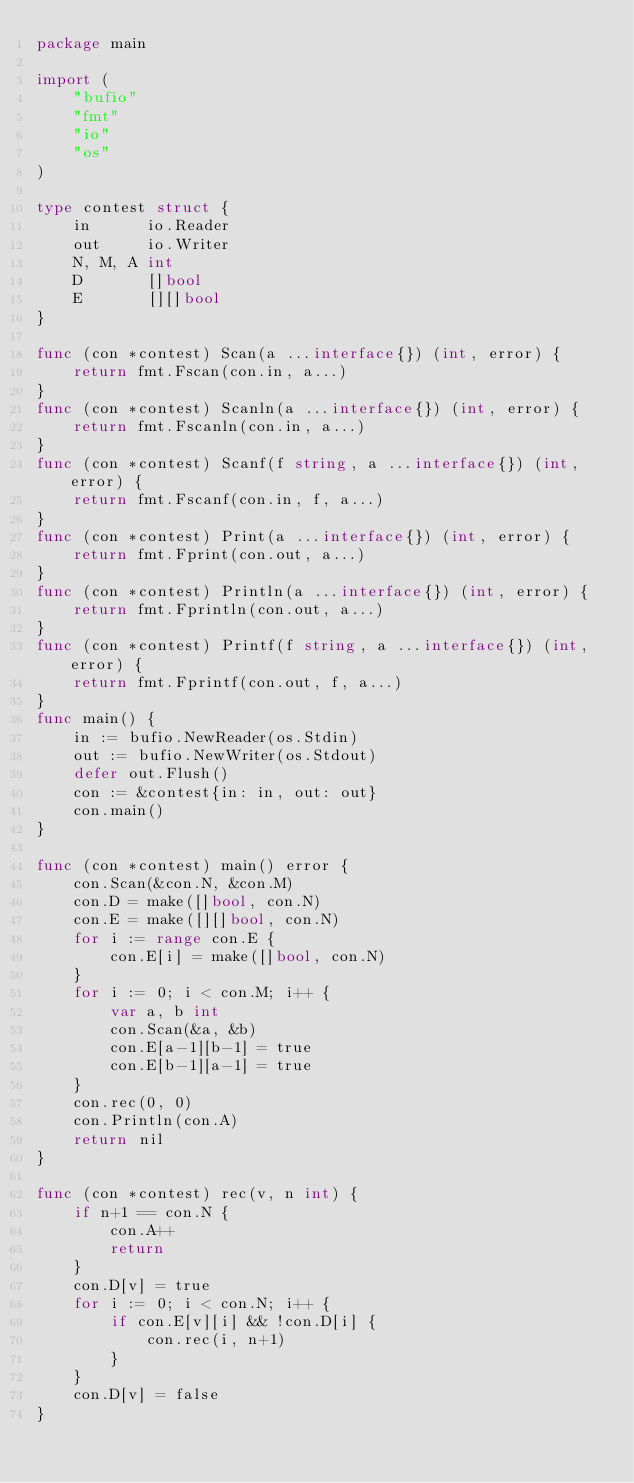<code> <loc_0><loc_0><loc_500><loc_500><_Go_>package main

import (
	"bufio"
	"fmt"
	"io"
	"os"
)

type contest struct {
	in      io.Reader
	out     io.Writer
	N, M, A int
	D       []bool
	E       [][]bool
}

func (con *contest) Scan(a ...interface{}) (int, error) {
	return fmt.Fscan(con.in, a...)
}
func (con *contest) Scanln(a ...interface{}) (int, error) {
	return fmt.Fscanln(con.in, a...)
}
func (con *contest) Scanf(f string, a ...interface{}) (int, error) {
	return fmt.Fscanf(con.in, f, a...)
}
func (con *contest) Print(a ...interface{}) (int, error) {
	return fmt.Fprint(con.out, a...)
}
func (con *contest) Println(a ...interface{}) (int, error) {
	return fmt.Fprintln(con.out, a...)
}
func (con *contest) Printf(f string, a ...interface{}) (int, error) {
	return fmt.Fprintf(con.out, f, a...)
}
func main() {
	in := bufio.NewReader(os.Stdin)
	out := bufio.NewWriter(os.Stdout)
	defer out.Flush()
	con := &contest{in: in, out: out}
	con.main()
}

func (con *contest) main() error {
	con.Scan(&con.N, &con.M)
	con.D = make([]bool, con.N)
	con.E = make([][]bool, con.N)
	for i := range con.E {
		con.E[i] = make([]bool, con.N)
	}
	for i := 0; i < con.M; i++ {
		var a, b int
		con.Scan(&a, &b)
		con.E[a-1][b-1] = true
		con.E[b-1][a-1] = true
	}
	con.rec(0, 0)
	con.Println(con.A)
	return nil
}

func (con *contest) rec(v, n int) {
	if n+1 == con.N {
		con.A++
		return
	}
	con.D[v] = true
	for i := 0; i < con.N; i++ {
		if con.E[v][i] && !con.D[i] {
			con.rec(i, n+1)
		}
	}
	con.D[v] = false
}
</code> 